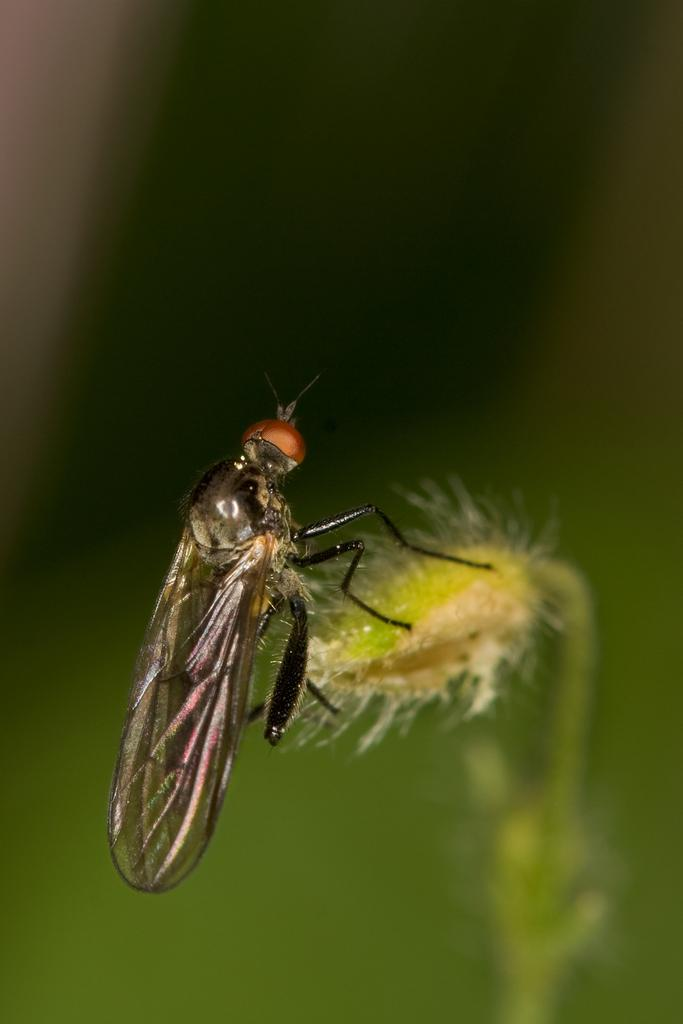What type of creature is present in the image? There is an insect with wings in the image. Where is the insect located? The insect is on a plant. What is the color of the background in the image? The background of the image is green and blurred. What type of furniture can be seen in the image? There is no furniture present in the image. What discovery was made by the insect in the image? The image does not depict any discovery made by the insect. 